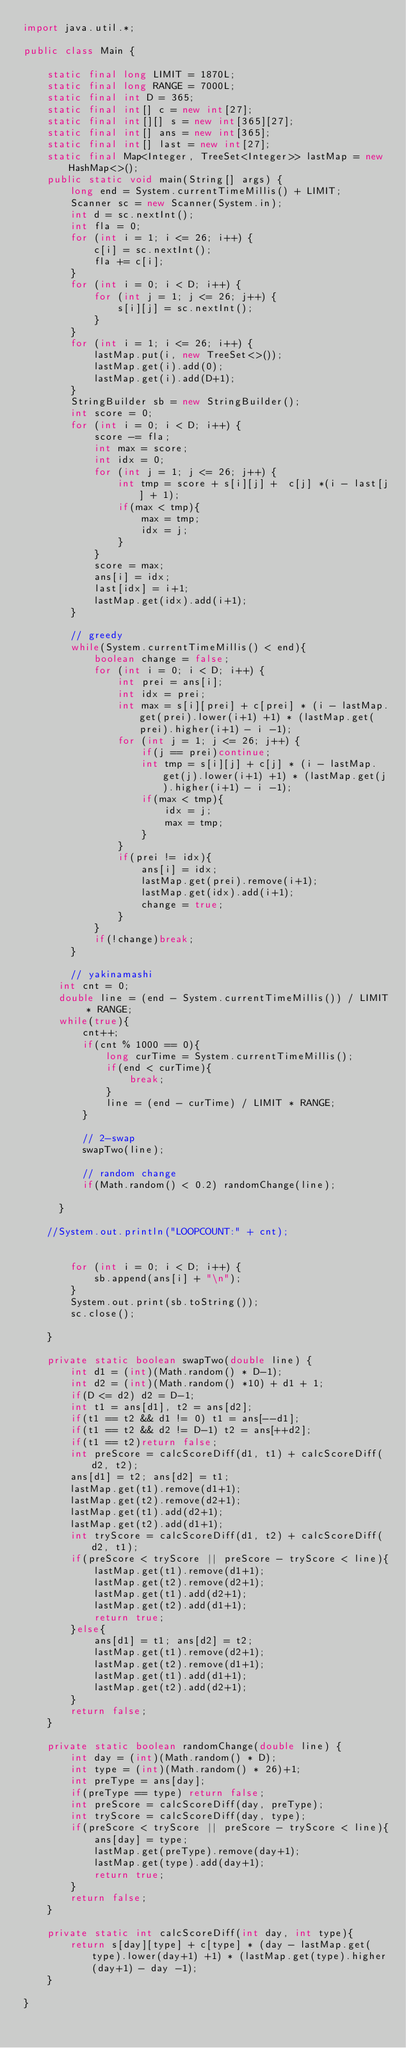<code> <loc_0><loc_0><loc_500><loc_500><_Java_>import java.util.*;

public class Main {

    static final long LIMIT = 1870L;
    static final long RANGE = 7000L;
    static final int D = 365;
    static final int[] c = new int[27];
    static final int[][] s = new int[365][27];
    static final int[] ans = new int[365];
    static final int[] last = new int[27];
    static final Map<Integer, TreeSet<Integer>> lastMap = new HashMap<>();
    public static void main(String[] args) {
        long end = System.currentTimeMillis() + LIMIT;
        Scanner sc = new Scanner(System.in);
        int d = sc.nextInt();
        int fla = 0;
        for (int i = 1; i <= 26; i++) {
            c[i] = sc.nextInt();
            fla += c[i];
        }
        for (int i = 0; i < D; i++) {
            for (int j = 1; j <= 26; j++) {
                s[i][j] = sc.nextInt();
            }
        }
        for (int i = 1; i <= 26; i++) {
            lastMap.put(i, new TreeSet<>());
            lastMap.get(i).add(0);
            lastMap.get(i).add(D+1);
        }
        StringBuilder sb = new StringBuilder();
        int score = 0;
        for (int i = 0; i < D; i++) {
            score -= fla;
            int max = score;
            int idx = 0;
            for (int j = 1; j <= 26; j++) {
                int tmp = score + s[i][j] +  c[j] *(i - last[j] + 1);
                if(max < tmp){
                    max = tmp;
                    idx = j;
                }
            }
            score = max;
            ans[i] = idx;
            last[idx] = i+1;
            lastMap.get(idx).add(i+1);
        }

        // greedy
        while(System.currentTimeMillis() < end){
            boolean change = false;
            for (int i = 0; i < D; i++) {
                int prei = ans[i];
                int idx = prei;
                int max = s[i][prei] + c[prei] * (i - lastMap.get(prei).lower(i+1) +1) * (lastMap.get(prei).higher(i+1) - i -1);
                for (int j = 1; j <= 26; j++) {
                    if(j == prei)continue;
                    int tmp = s[i][j] + c[j] * (i - lastMap.get(j).lower(i+1) +1) * (lastMap.get(j).higher(i+1) - i -1);
                    if(max < tmp){
                        idx = j;
                        max = tmp;
                    }
                }
                if(prei != idx){
                    ans[i] = idx;
                    lastMap.get(prei).remove(i+1);
                    lastMap.get(idx).add(i+1);
                    change = true;
                }
            }
            if(!change)break;
        }

        // yakinamashi
      int cnt = 0;
      double line = (end - System.currentTimeMillis()) / LIMIT * RANGE;
      while(true){
          cnt++;
          if(cnt % 1000 == 0){
              long curTime = System.currentTimeMillis();
              if(end < curTime){
                  break;
              }
              line = (end - curTime) / LIMIT * RANGE;
          }

          // 2-swap
          swapTwo(line);

          // random change
          if(Math.random() < 0.2) randomChange(line);

      }

    //System.out.println("LOOPCOUNT:" + cnt);


        for (int i = 0; i < D; i++) {
            sb.append(ans[i] + "\n");
        }
        System.out.print(sb.toString());
        sc.close();

    }

    private static boolean swapTwo(double line) {
        int d1 = (int)(Math.random() * D-1);
        int d2 = (int)(Math.random() *10) + d1 + 1;
        if(D <= d2) d2 = D-1;
        int t1 = ans[d1], t2 = ans[d2];
        if(t1 == t2 && d1 != 0) t1 = ans[--d1];
        if(t1 == t2 && d2 != D-1) t2 = ans[++d2];
        if(t1 == t2)return false;
        int preScore = calcScoreDiff(d1, t1) + calcScoreDiff(d2, t2);
        ans[d1] = t2; ans[d2] = t1;
        lastMap.get(t1).remove(d1+1);
        lastMap.get(t2).remove(d2+1);
        lastMap.get(t1).add(d2+1);
        lastMap.get(t2).add(d1+1);
        int tryScore = calcScoreDiff(d1, t2) + calcScoreDiff(d2, t1);
        if(preScore < tryScore || preScore - tryScore < line){
            lastMap.get(t1).remove(d1+1);
            lastMap.get(t2).remove(d2+1);
            lastMap.get(t1).add(d2+1);
            lastMap.get(t2).add(d1+1);
            return true;
        }else{
            ans[d1] = t1; ans[d2] = t2;
            lastMap.get(t1).remove(d2+1);
            lastMap.get(t2).remove(d1+1);
            lastMap.get(t1).add(d1+1);
            lastMap.get(t2).add(d2+1);
        }
        return false;
    }

    private static boolean randomChange(double line) {
        int day = (int)(Math.random() * D);
        int type = (int)(Math.random() * 26)+1;
        int preType = ans[day];
        if(preType == type) return false;
        int preScore = calcScoreDiff(day, preType);
        int tryScore = calcScoreDiff(day, type);
        if(preScore < tryScore || preScore - tryScore < line){
            ans[day] = type;
            lastMap.get(preType).remove(day+1);
            lastMap.get(type).add(day+1);
            return true;
        }
        return false;
    }

    private static int calcScoreDiff(int day, int type){
        return s[day][type] + c[type] * (day - lastMap.get(type).lower(day+1) +1) * (lastMap.get(type).higher(day+1) - day -1);
    }

}
</code> 